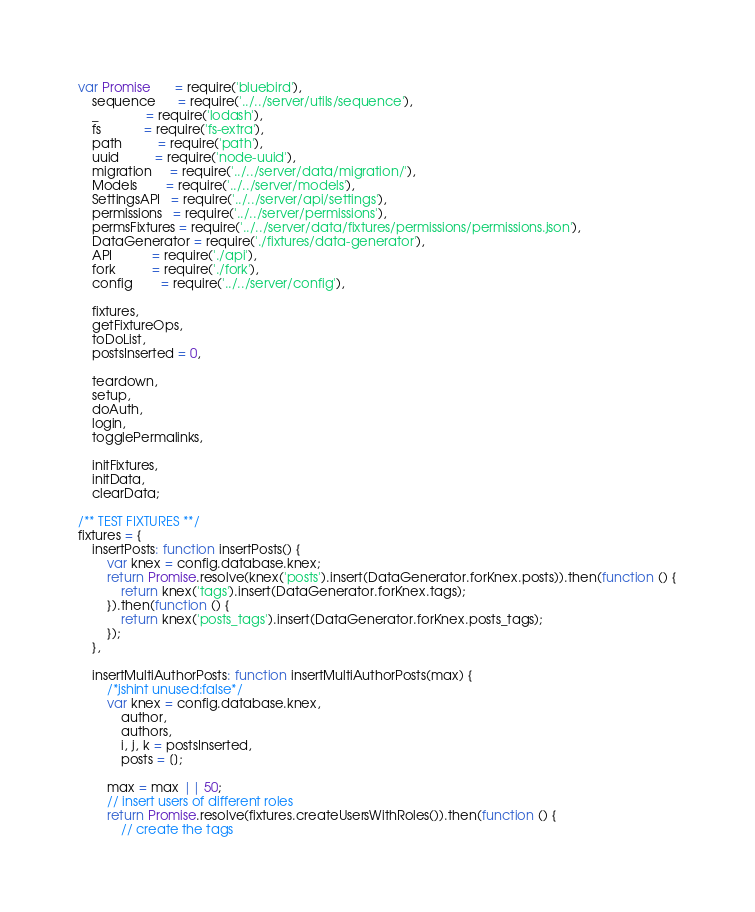Convert code to text. <code><loc_0><loc_0><loc_500><loc_500><_JavaScript_>var Promise       = require('bluebird'),
    sequence      = require('../../server/utils/sequence'),
    _             = require('lodash'),
    fs            = require('fs-extra'),
    path          = require('path'),
    uuid          = require('node-uuid'),
    migration     = require('../../server/data/migration/'),
    Models        = require('../../server/models'),
    SettingsAPI   = require('../../server/api/settings'),
    permissions   = require('../../server/permissions'),
    permsFixtures = require('../../server/data/fixtures/permissions/permissions.json'),
    DataGenerator = require('./fixtures/data-generator'),
    API           = require('./api'),
    fork          = require('./fork'),
    config        = require('../../server/config'),

    fixtures,
    getFixtureOps,
    toDoList,
    postsInserted = 0,

    teardown,
    setup,
    doAuth,
    login,
    togglePermalinks,

    initFixtures,
    initData,
    clearData;

/** TEST FIXTURES **/
fixtures = {
    insertPosts: function insertPosts() {
        var knex = config.database.knex;
        return Promise.resolve(knex('posts').insert(DataGenerator.forKnex.posts)).then(function () {
            return knex('tags').insert(DataGenerator.forKnex.tags);
        }).then(function () {
            return knex('posts_tags').insert(DataGenerator.forKnex.posts_tags);
        });
    },

    insertMultiAuthorPosts: function insertMultiAuthorPosts(max) {
        /*jshint unused:false*/
        var knex = config.database.knex,
            author,
            authors,
            i, j, k = postsInserted,
            posts = [];

        max = max || 50;
        // insert users of different roles
        return Promise.resolve(fixtures.createUsersWithRoles()).then(function () {
            // create the tags</code> 